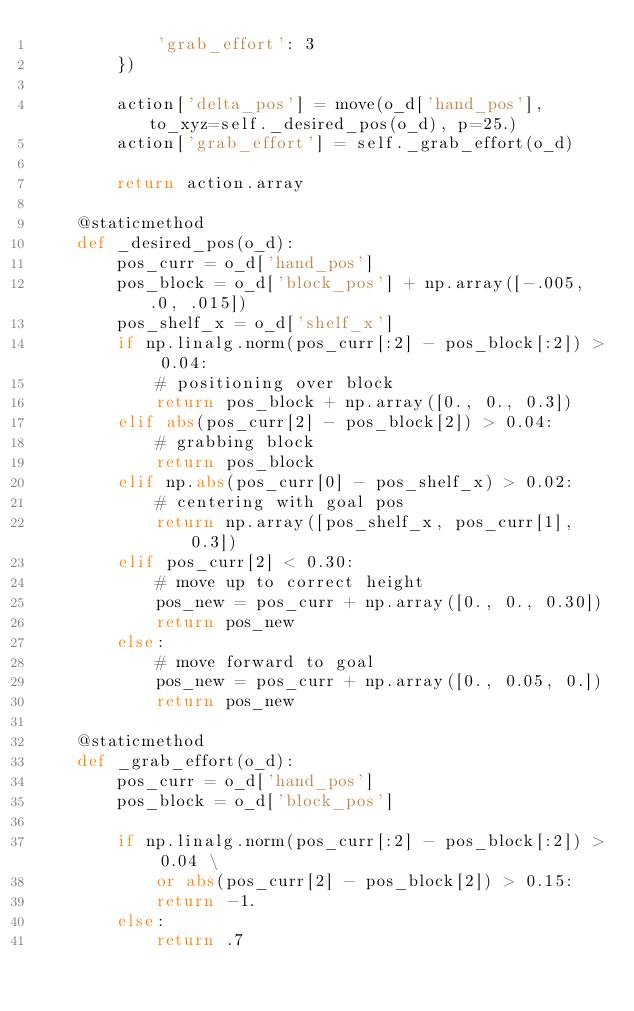Convert code to text. <code><loc_0><loc_0><loc_500><loc_500><_Python_>            'grab_effort': 3
        })

        action['delta_pos'] = move(o_d['hand_pos'], to_xyz=self._desired_pos(o_d), p=25.)
        action['grab_effort'] = self._grab_effort(o_d)

        return action.array

    @staticmethod
    def _desired_pos(o_d):
        pos_curr = o_d['hand_pos']
        pos_block = o_d['block_pos'] + np.array([-.005, .0, .015])
        pos_shelf_x = o_d['shelf_x']
        if np.linalg.norm(pos_curr[:2] - pos_block[:2]) > 0.04:
            # positioning over block
            return pos_block + np.array([0., 0., 0.3])
        elif abs(pos_curr[2] - pos_block[2]) > 0.04:
            # grabbing block
            return pos_block
        elif np.abs(pos_curr[0] - pos_shelf_x) > 0.02:
            # centering with goal pos
            return np.array([pos_shelf_x, pos_curr[1], 0.3])
        elif pos_curr[2] < 0.30:
            # move up to correct height
            pos_new = pos_curr + np.array([0., 0., 0.30])
            return pos_new
        else:
            # move forward to goal
            pos_new = pos_curr + np.array([0., 0.05, 0.])
            return pos_new

    @staticmethod
    def _grab_effort(o_d):
        pos_curr = o_d['hand_pos']
        pos_block = o_d['block_pos']

        if np.linalg.norm(pos_curr[:2] - pos_block[:2]) > 0.04 \
            or abs(pos_curr[2] - pos_block[2]) > 0.15:
            return -1.
        else:
            return .7
</code> 